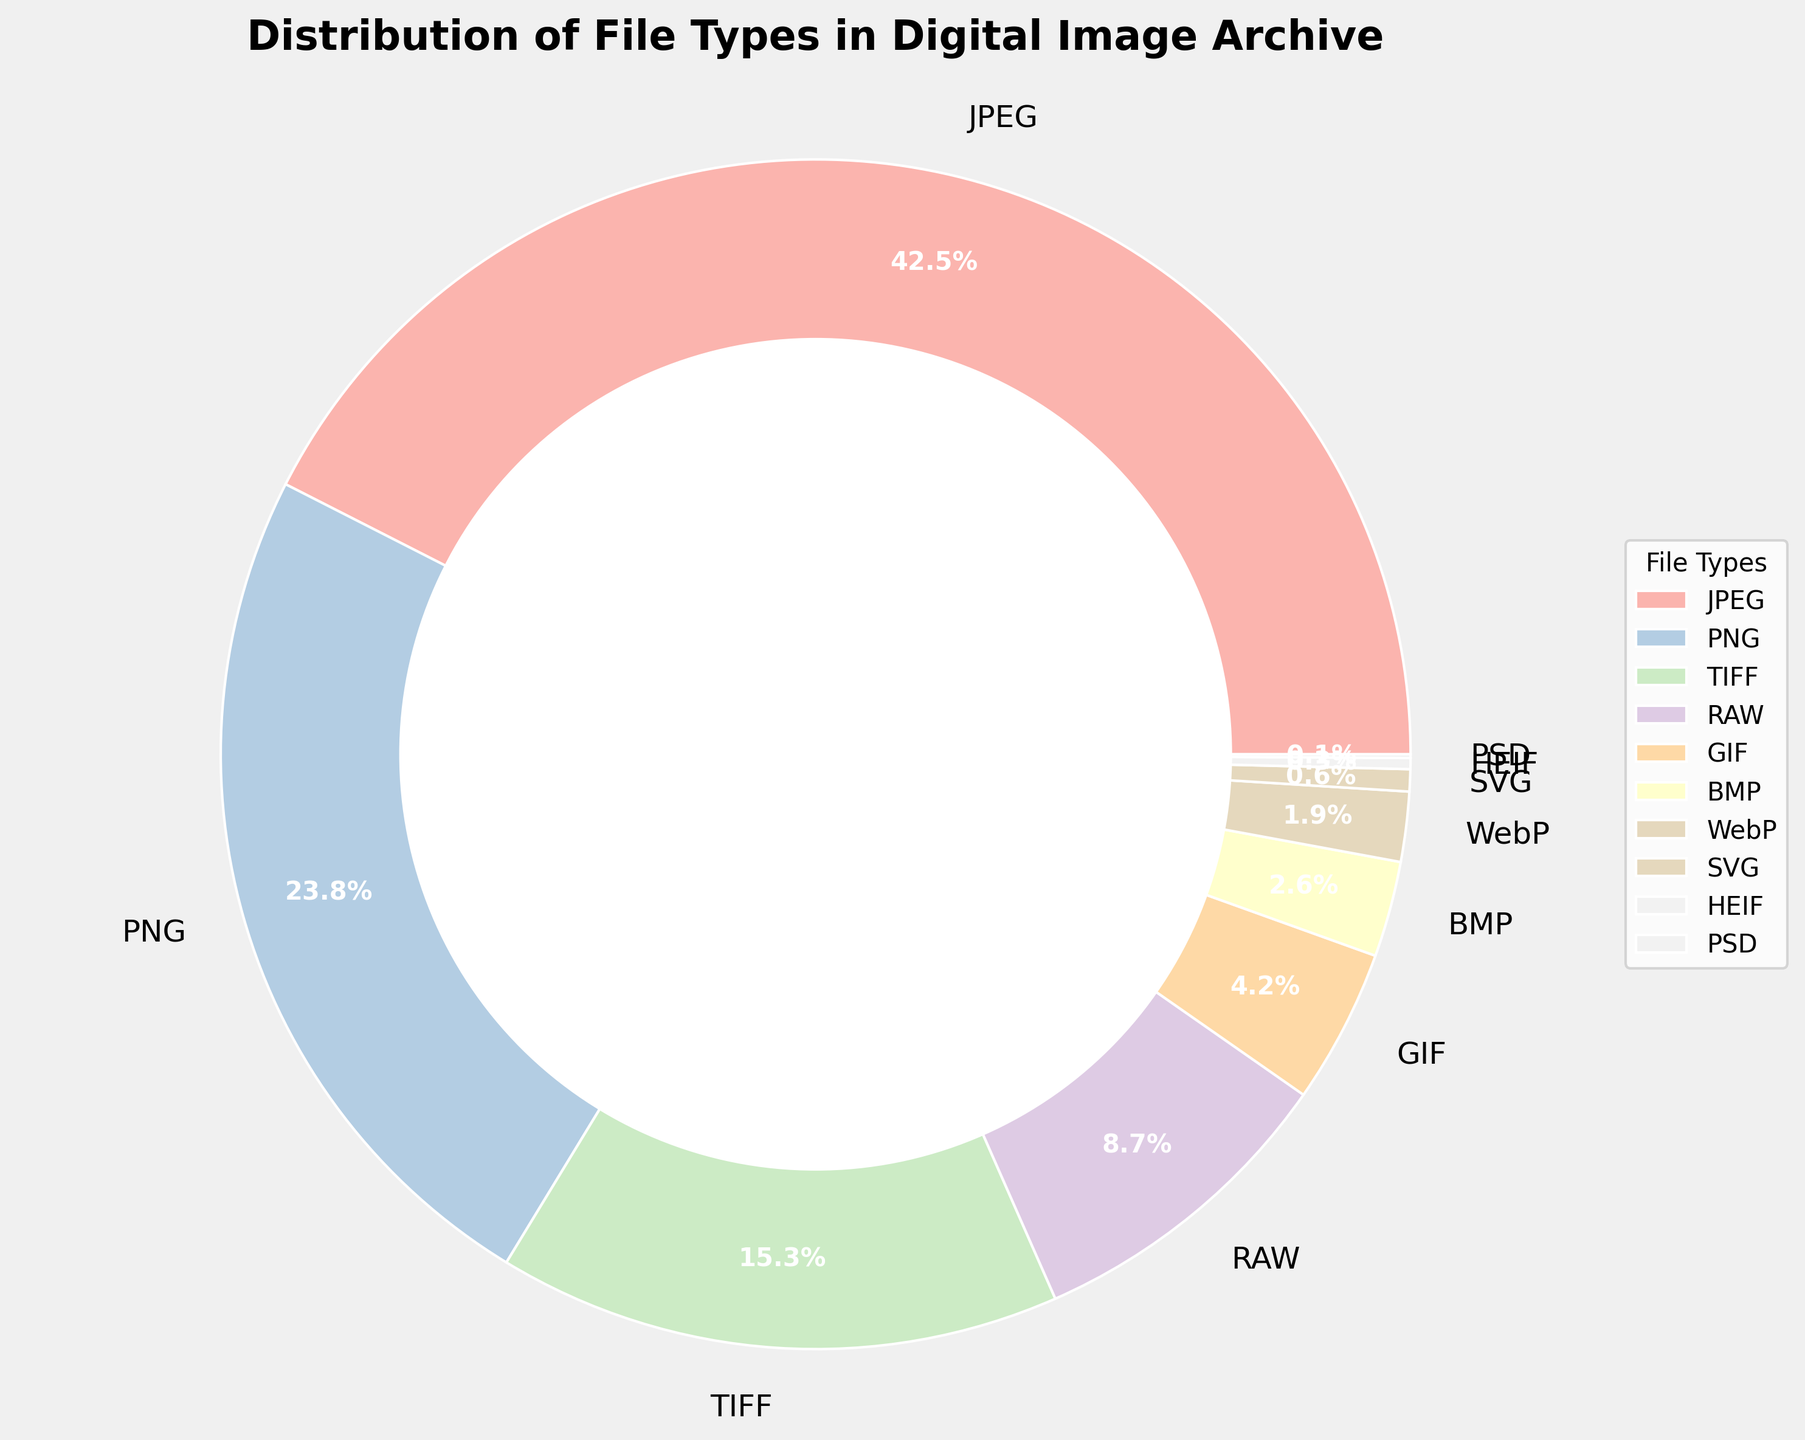What percentage of the archive is composed of JPEG and PNG files combined? Sum the percentages of JPEG and PNG categories from the pie chart: 42.5% (JPEG) + 23.8% (PNG) = 66.3%.
Answer: 66.3% Which file type occupies the smallest portion of the archive? Identify the file type with the smallest percentage in the pie chart, which is PSD with 0.1%.
Answer: PSD How does the percentage of RAW files compare to TIFF files? Compare the percentages of RAW and TIFF from the pie chart: RAW is 8.7% and TIFF is 15.3%; RAW is less than TIFF.
Answer: Less What is the combined percentage of the rarest three file types? Identify the three file types with the smallest percentages: PSD (0.1%), HEIF (0.3%), and SVG (0.6%). Sum them up: 0.1% + 0.3% + 0.6% = 1.0%.
Answer: 1.0% Which file type occupies just above 4% of the archive? Identify the file type from the pie chart with a percentage slightly above 4%, which is GIF with 4.2%.
Answer: GIF What is the percentage difference between BMP and WebP files? Calculate the difference between the percentages of BMP and WebP from the pie chart: 2.6% (BMP) - 1.9% (WebP) = 0.7%.
Answer: 0.7% Which file type is represented by the largest section in pastel colors on the chart? Identify the file type with the largest percentage in the pie chart, which is JPEG with 42.5%.
Answer: JPEG Between PNG and GIF, which file type has a higher percentage and by how much? Compare the percentages of PNG and GIF from the pie chart and calculate the difference: 23.8% (PNG) - 4.2% (GIF) = 19.6%. PNG has a higher percentage by 19.6%.
Answer: PNG by 19.6% How many file types account for more than 15% of the archive? Identify the file types with percentages greater than 15% from the pie chart: JPEG (42.5%) and PNG (23.8%). Only 2 file types meet this criterion.
Answer: 2 Is the percentage of TIFF files greater than the sum of BMP and WebP files? Sum the percentages of BMP and WebP from the pie chart: 2.6% (BMP) + 1.9% (WebP) = 4.5%. Compare this sum to the percentage of TIFF: 15.3% (TIFF). Since 15.3% is greater than 4.5%, the answer is yes.
Answer: Yes 